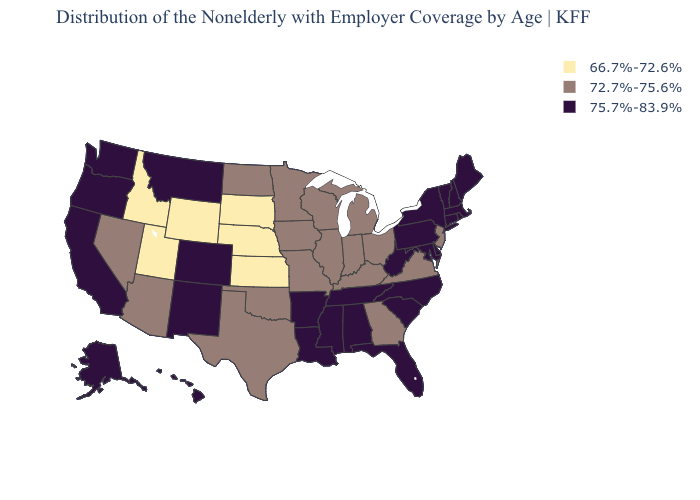Does South Dakota have the lowest value in the USA?
Concise answer only. Yes. What is the value of Washington?
Give a very brief answer. 75.7%-83.9%. What is the highest value in states that border Idaho?
Concise answer only. 75.7%-83.9%. What is the value of North Dakota?
Be succinct. 72.7%-75.6%. Name the states that have a value in the range 72.7%-75.6%?
Give a very brief answer. Arizona, Georgia, Illinois, Indiana, Iowa, Kentucky, Michigan, Minnesota, Missouri, Nevada, New Jersey, North Dakota, Ohio, Oklahoma, Texas, Virginia, Wisconsin. Which states have the lowest value in the MidWest?
Quick response, please. Kansas, Nebraska, South Dakota. What is the highest value in the USA?
Be succinct. 75.7%-83.9%. What is the highest value in states that border Florida?
Be succinct. 75.7%-83.9%. Does Michigan have a lower value than Hawaii?
Concise answer only. Yes. Among the states that border Alabama , which have the highest value?
Write a very short answer. Florida, Mississippi, Tennessee. Does Utah have the lowest value in the USA?
Be succinct. Yes. Which states have the lowest value in the USA?
Concise answer only. Idaho, Kansas, Nebraska, South Dakota, Utah, Wyoming. What is the value of New Jersey?
Be succinct. 72.7%-75.6%. What is the lowest value in the South?
Give a very brief answer. 72.7%-75.6%. 